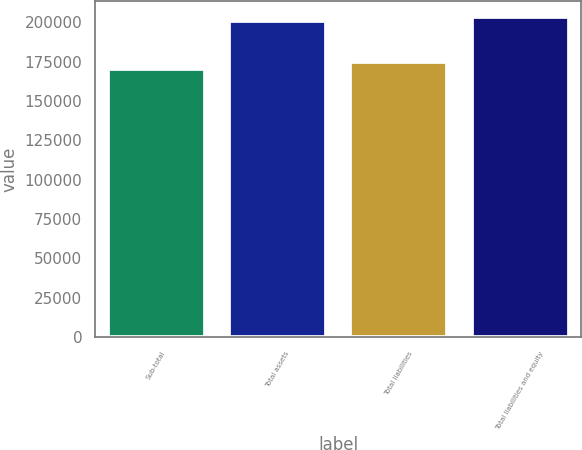Convert chart. <chart><loc_0><loc_0><loc_500><loc_500><bar_chart><fcel>Sub-total<fcel>Total assets<fcel>Total liabilities<fcel>Total liabilities and equity<nl><fcel>170139<fcel>200451<fcel>174834<fcel>203482<nl></chart> 